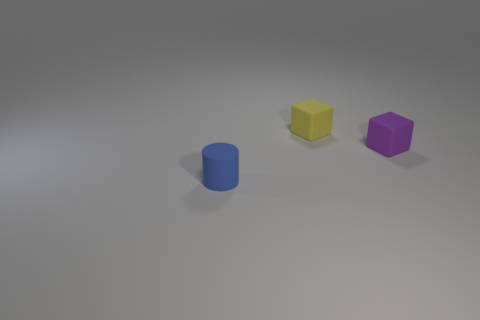Are there more yellow blocks in front of the rubber cylinder than small rubber blocks that are in front of the purple object?
Ensure brevity in your answer.  No. There is a matte thing that is behind the tiny thing that is to the right of the rubber block on the left side of the purple thing; how big is it?
Keep it short and to the point. Small. Are there any blocks that have the same color as the rubber cylinder?
Offer a terse response. No. How many small blue matte objects are there?
Offer a terse response. 1. There is a small cube that is on the right side of the rubber cube that is behind the block that is on the right side of the yellow object; what is it made of?
Provide a short and direct response. Rubber. Is there another small object made of the same material as the small yellow object?
Your answer should be compact. Yes. Does the blue object have the same material as the small purple object?
Ensure brevity in your answer.  Yes. What number of balls are small purple things or yellow shiny objects?
Give a very brief answer. 0. What color is the cylinder that is the same material as the yellow block?
Ensure brevity in your answer.  Blue. Are there fewer big red cubes than small purple matte blocks?
Your answer should be very brief. Yes. 